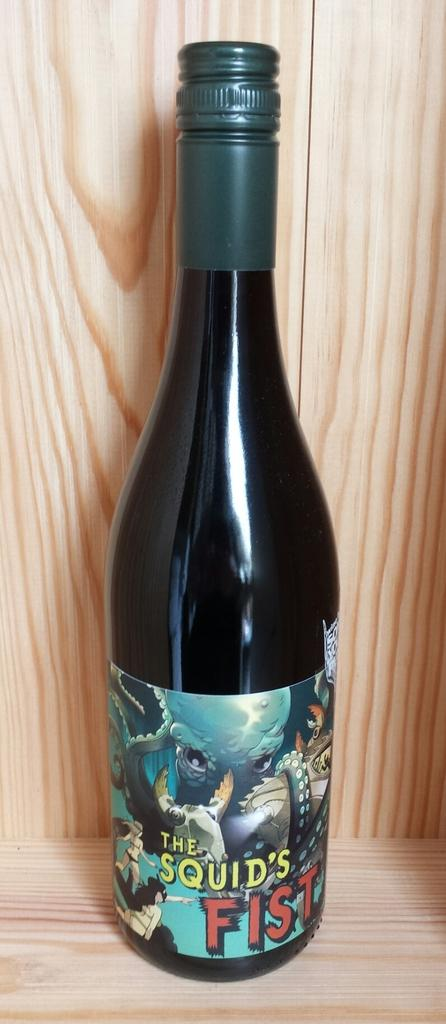<image>
Describe the image concisely. A tall bottle of The Squid's Fist wine on a wooden shelf. 